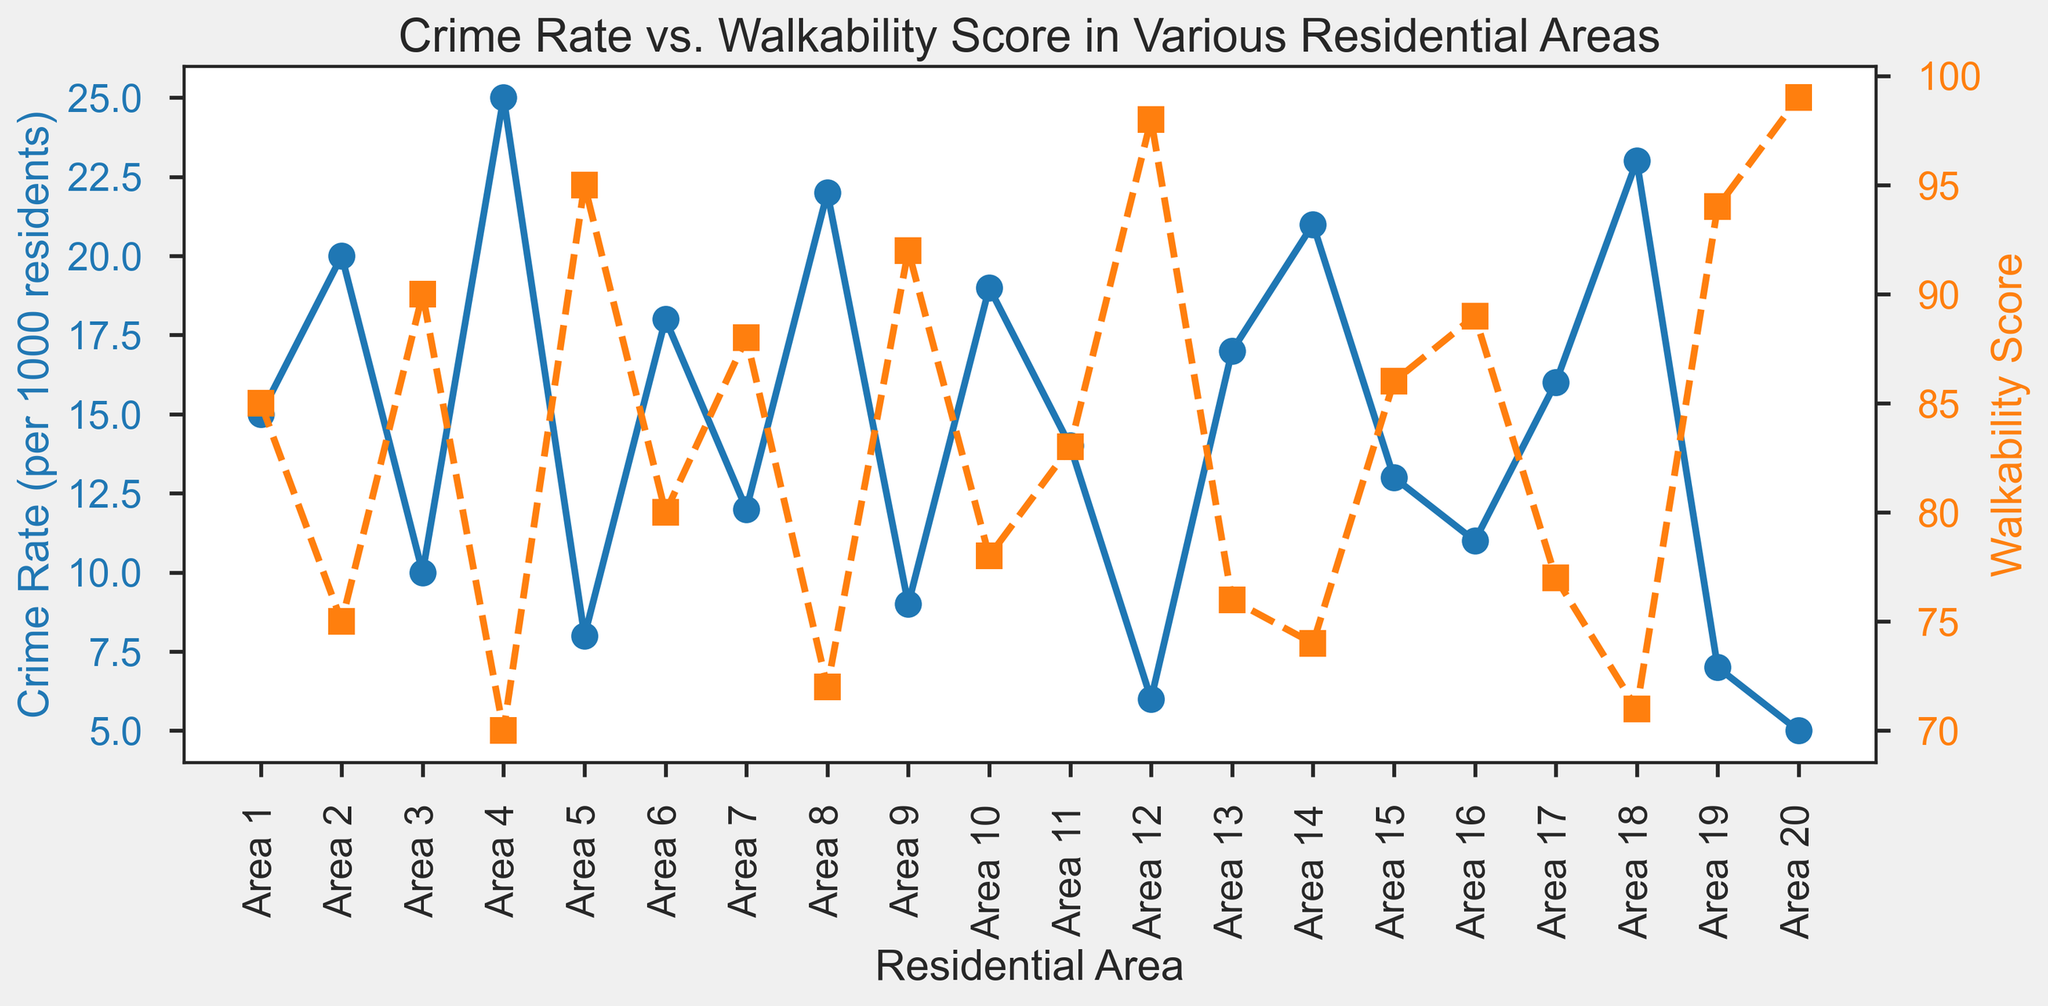How many areas have a crime rate below 10 per 1000 residents? To find the answer, visually scan the plot of crime rates and count the areas where the plot points fall below the 10 per 1000 residents mark.
Answer: 5 Which area has the highest walkability score, and what is its crime rate? Identify the area with the highest position on the walkability score (orange line with square markers) and note its corresponding crime rate (blue line with circle markers). The highest walkability score is 99 for Area 20, with a crime rate of 5 per 1000 residents.
Answer: Area 20, 5 Are there any areas where both the crime rate is below 10 and the walkability score is above 90? If so, name them. Look for points where the crime rate, indicated by the blue circles, is below 10, and the walkability score, indicated by the orange squares, is above 90. Area 12 and Area 20 meet these criteria.
Answer: Area 12, Area 20 What is the average walkability score of the three areas with the lowest crime rates? Identify the three lowest crime rate areas (Areas 20, 12, and 19 with rates of 5, 6, and 7 respectively) and find their corresponding walkability scores (99, 98, and 94). Then, calculate the average: (99 + 98 + 94) / 3.
Answer: 97 Which area has the largest discrepancy between crime rate and walkability score? Calculate the absolute difference between crime rate and walkability score for each area. The largest discrepancy occurs in Area 12, where the crime rate is 6 and the walkability score is 98, resulting in a difference of 92.
Answer: Area 12 Compare the crime rates of the areas with the highest and lowest walkability scores. What do you observe? Area 20 has the highest walkability score of 99 and a crime rate of 5 per 1000 residents, while Area 4 has the lowest walkability score of 70 and a crime rate of 25 per 1000 residents. The area with the highest walkability has a significantly lower crime rate compared to the area with the lowest walkability.
Answer: Highest (5) vs. Lowest (25) Is there an obvious visual relationship between walkability score and crime rate? Analyzing the overall trend of both plots, it becomes apparent that areas with higher walkability scores (orange line with squares) generally seem to have lower crime rates (blue line with circles). This suggests an inverse relationship between walkability and crime rate.
Answer: Inverse relationship For Area 16, does it have a higher walkability score, a lower walkability score, or an equally high walkability score compared to Area 7? What about their crime rates? Compare Area 16 and Area 7 using their visual markers on both axes. Area 16 has a higher walkability score (89) compared to Area 7 (88). Similarly, the crime rate of Area 16 (11) is lower than that of Area 7 (12).
Answer: Higher, Lower Calculate the range of walkability scores across all areas. The range is found by subtracting the smallest walkability score (70) from the largest walkability score (99). Range = 99 - 70.
Answer: 29 